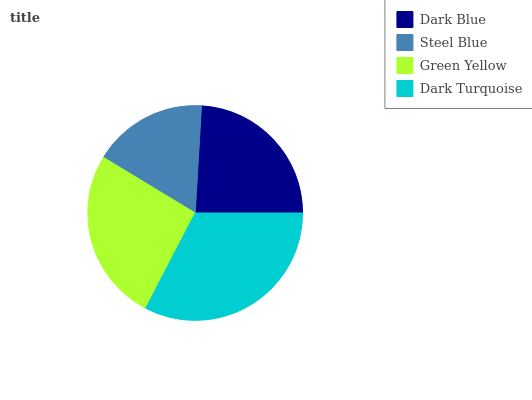Is Steel Blue the minimum?
Answer yes or no. Yes. Is Dark Turquoise the maximum?
Answer yes or no. Yes. Is Green Yellow the minimum?
Answer yes or no. No. Is Green Yellow the maximum?
Answer yes or no. No. Is Green Yellow greater than Steel Blue?
Answer yes or no. Yes. Is Steel Blue less than Green Yellow?
Answer yes or no. Yes. Is Steel Blue greater than Green Yellow?
Answer yes or no. No. Is Green Yellow less than Steel Blue?
Answer yes or no. No. Is Green Yellow the high median?
Answer yes or no. Yes. Is Dark Blue the low median?
Answer yes or no. Yes. Is Dark Turquoise the high median?
Answer yes or no. No. Is Steel Blue the low median?
Answer yes or no. No. 